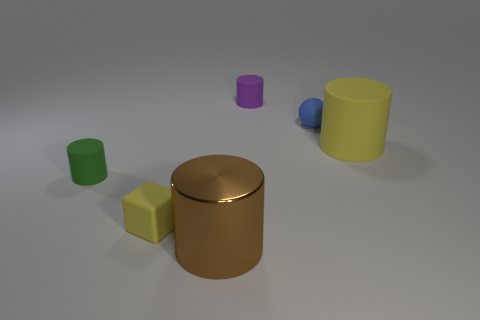Is there any other thing that is the same material as the big brown cylinder?
Give a very brief answer. No. Is there a tiny yellow thing of the same shape as the big metal thing?
Offer a terse response. No. Do the large brown object and the green matte object have the same shape?
Keep it short and to the point. Yes. What number of small things are either yellow cylinders or brown cubes?
Make the answer very short. 0. Is the number of cubes greater than the number of big yellow blocks?
Offer a very short reply. Yes. There is a block that is made of the same material as the small blue ball; what size is it?
Offer a very short reply. Small. Does the matte cylinder behind the tiny blue rubber object have the same size as the yellow thing that is in front of the green cylinder?
Make the answer very short. Yes. What number of objects are either tiny things in front of the tiny green matte object or small matte spheres?
Keep it short and to the point. 2. Are there fewer small green matte things than tiny brown metallic blocks?
Ensure brevity in your answer.  No. What shape is the big thing that is in front of the tiny cylinder in front of the tiny blue thing behind the large brown metallic thing?
Your answer should be very brief. Cylinder. 